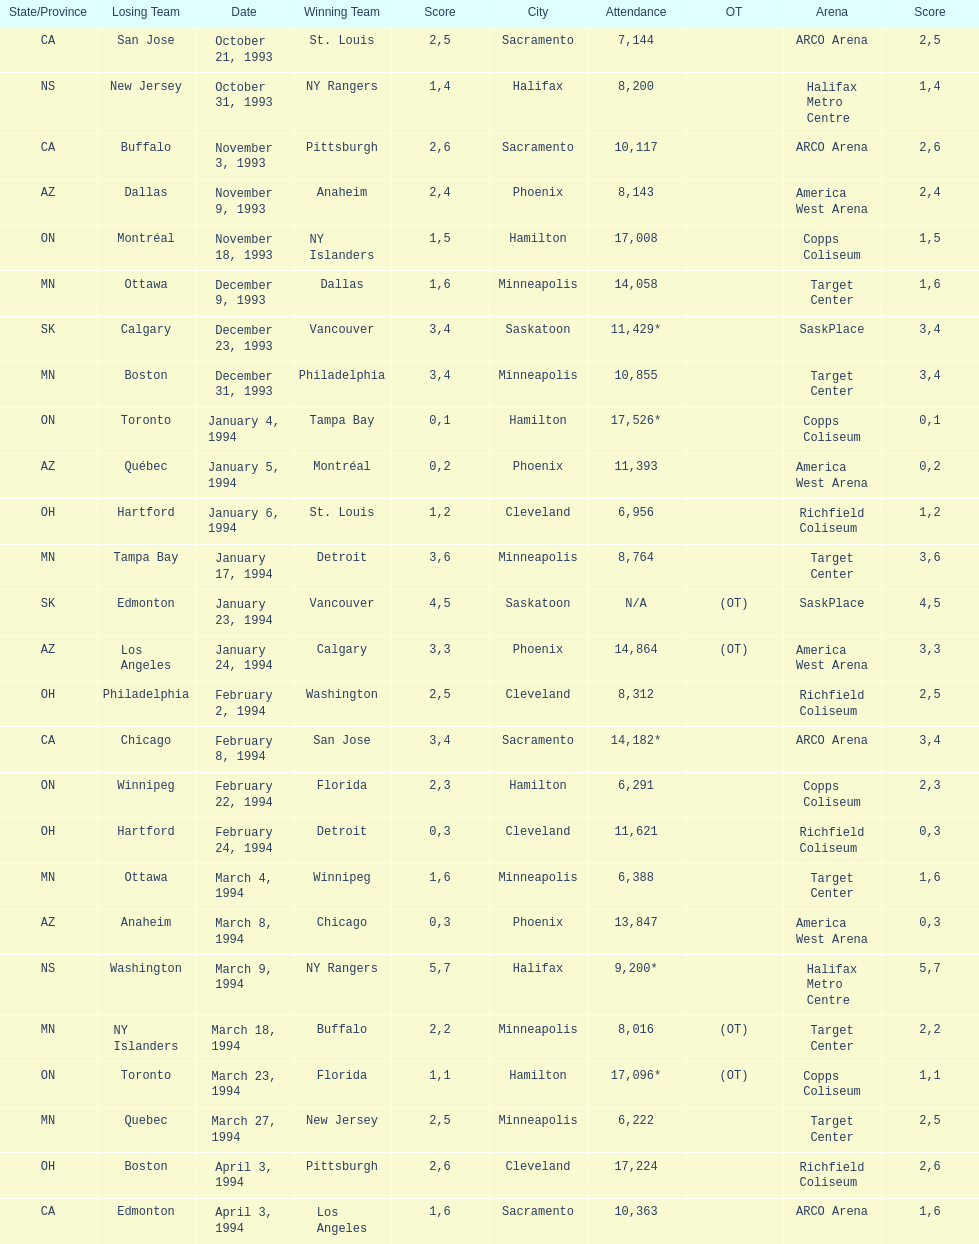How many games have been held in minneapolis? 6. 